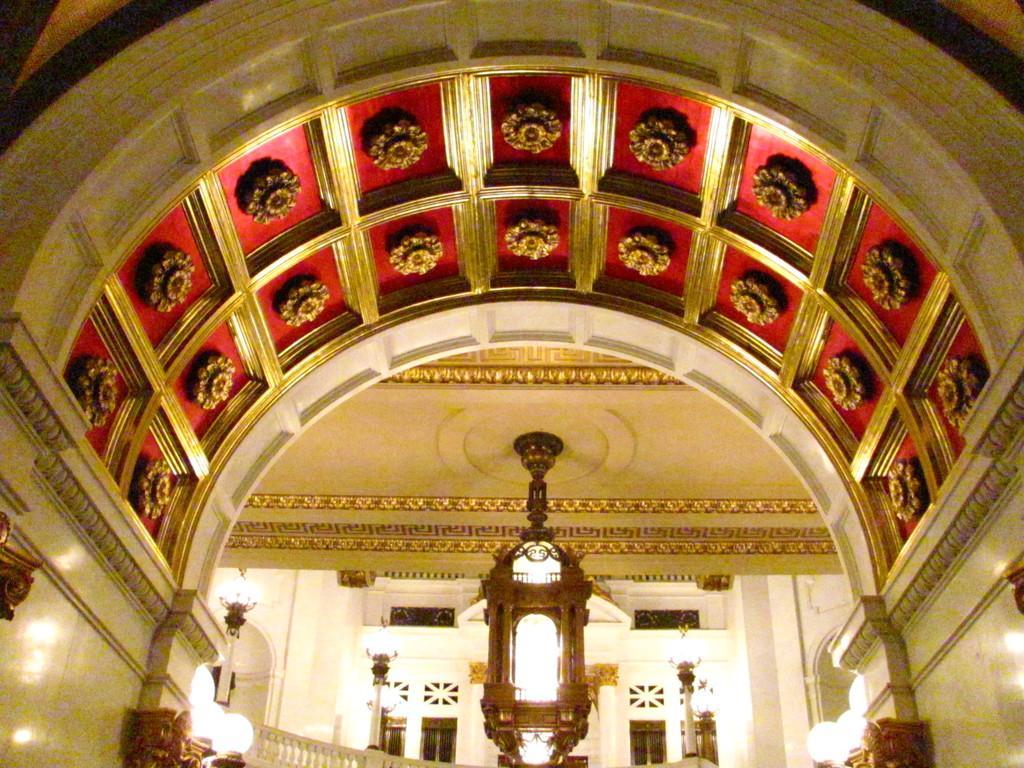Can you describe this image briefly? This picture is clicked inside the building. In the middle of the picture, we see a pillar and beside that, we see a staircase. In the background, we see doors and windows. We even see a wall in white color. At the top of the picture, we see the ceiling of the room. 